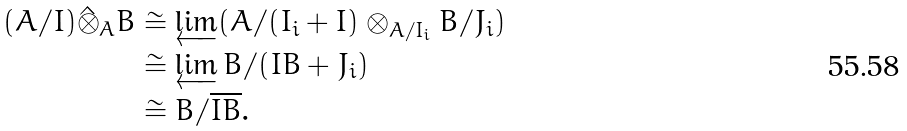Convert formula to latex. <formula><loc_0><loc_0><loc_500><loc_500>( A / I ) \hat { \otimes } _ { A } B & \cong \varprojlim ( A / ( I _ { i } + I ) \otimes _ { A / I _ { i } } B / J _ { i } ) \\ & \cong \varprojlim B / ( I B + J _ { i } ) \\ & \cong B / \overline { I B } .</formula> 